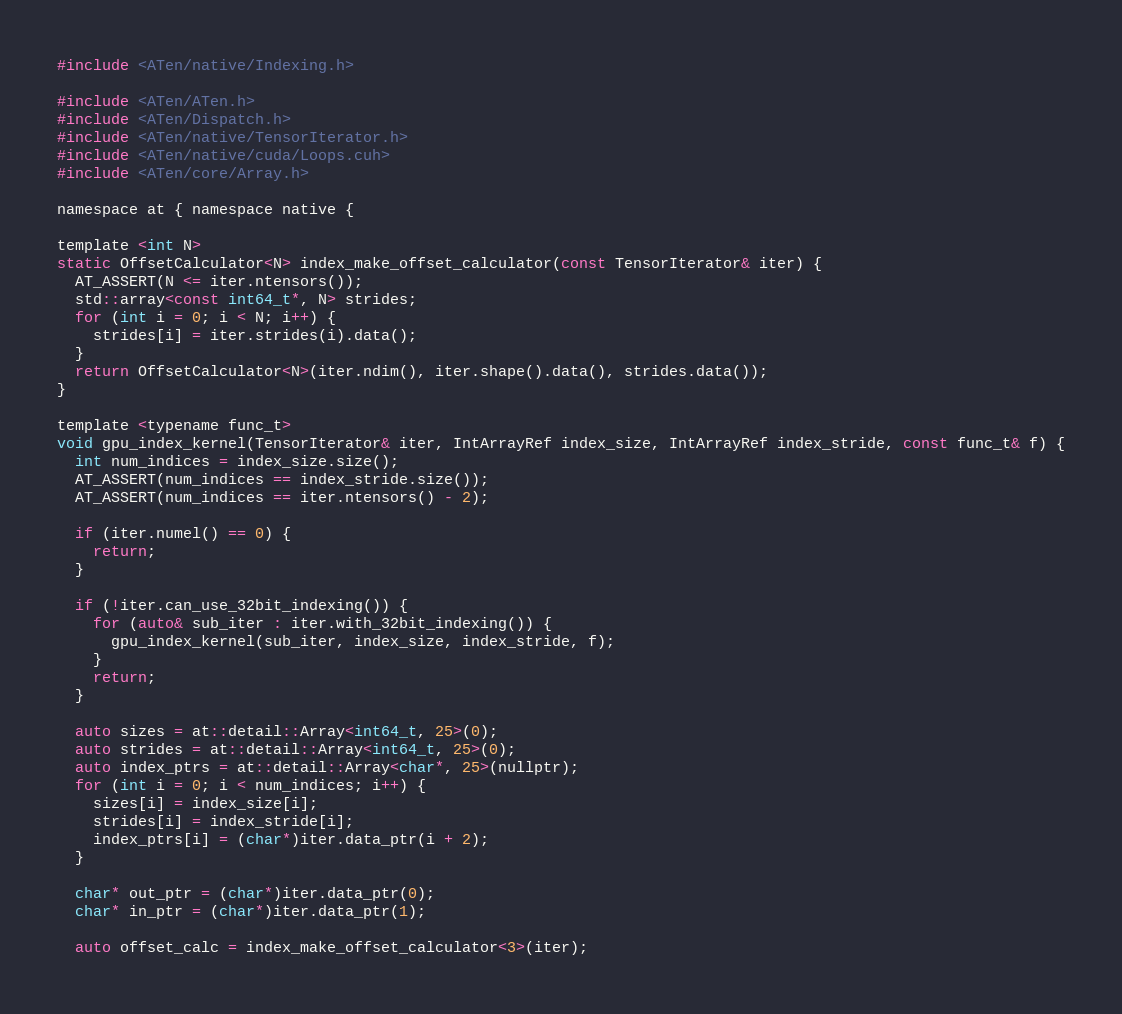Convert code to text. <code><loc_0><loc_0><loc_500><loc_500><_Cuda_>#include <ATen/native/Indexing.h>

#include <ATen/ATen.h>
#include <ATen/Dispatch.h>
#include <ATen/native/TensorIterator.h>
#include <ATen/native/cuda/Loops.cuh>
#include <ATen/core/Array.h>

namespace at { namespace native {

template <int N>
static OffsetCalculator<N> index_make_offset_calculator(const TensorIterator& iter) {
  AT_ASSERT(N <= iter.ntensors());
  std::array<const int64_t*, N> strides;
  for (int i = 0; i < N; i++) {
    strides[i] = iter.strides(i).data();
  }
  return OffsetCalculator<N>(iter.ndim(), iter.shape().data(), strides.data());
}

template <typename func_t>
void gpu_index_kernel(TensorIterator& iter, IntArrayRef index_size, IntArrayRef index_stride, const func_t& f) {
  int num_indices = index_size.size();
  AT_ASSERT(num_indices == index_stride.size());
  AT_ASSERT(num_indices == iter.ntensors() - 2);

  if (iter.numel() == 0) {
    return;
  }

  if (!iter.can_use_32bit_indexing()) {
    for (auto& sub_iter : iter.with_32bit_indexing()) {
      gpu_index_kernel(sub_iter, index_size, index_stride, f);
    }
    return;
  }

  auto sizes = at::detail::Array<int64_t, 25>(0);
  auto strides = at::detail::Array<int64_t, 25>(0);
  auto index_ptrs = at::detail::Array<char*, 25>(nullptr);
  for (int i = 0; i < num_indices; i++) {
    sizes[i] = index_size[i];
    strides[i] = index_stride[i];
    index_ptrs[i] = (char*)iter.data_ptr(i + 2);
  }

  char* out_ptr = (char*)iter.data_ptr(0);
  char* in_ptr = (char*)iter.data_ptr(1);

  auto offset_calc = index_make_offset_calculator<3>(iter);</code> 